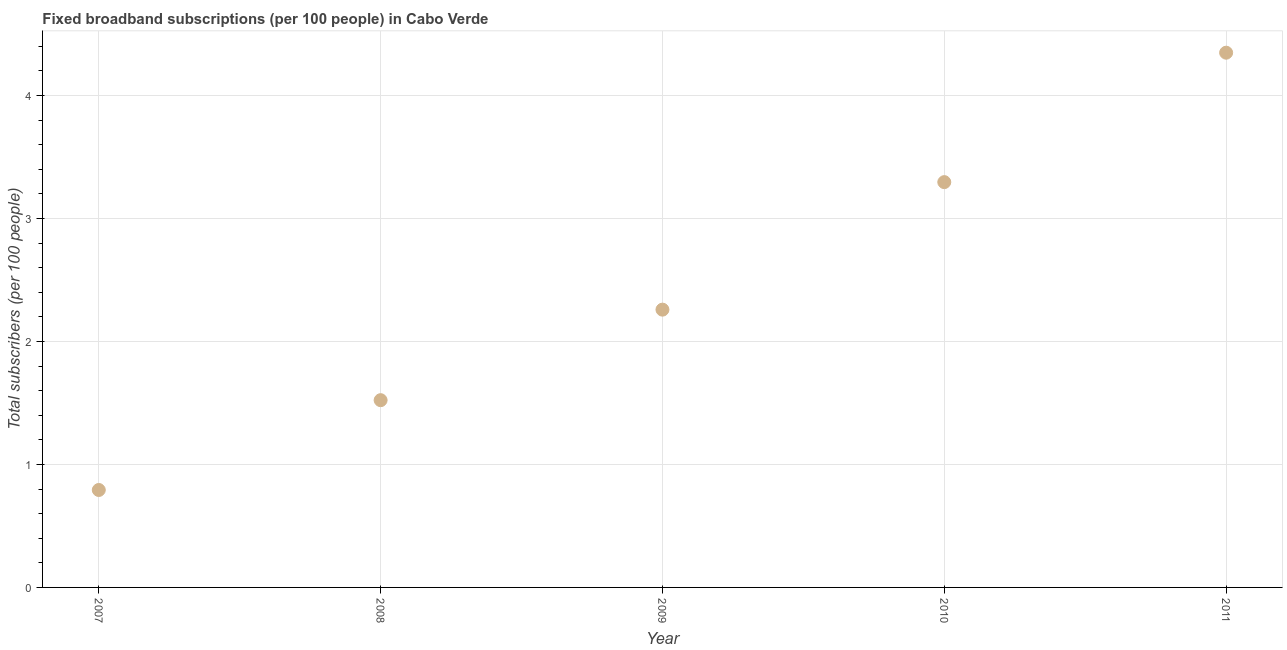What is the total number of fixed broadband subscriptions in 2010?
Offer a terse response. 3.3. Across all years, what is the maximum total number of fixed broadband subscriptions?
Your answer should be very brief. 4.35. Across all years, what is the minimum total number of fixed broadband subscriptions?
Make the answer very short. 0.79. In which year was the total number of fixed broadband subscriptions minimum?
Provide a short and direct response. 2007. What is the sum of the total number of fixed broadband subscriptions?
Provide a succinct answer. 12.22. What is the difference between the total number of fixed broadband subscriptions in 2009 and 2010?
Make the answer very short. -1.04. What is the average total number of fixed broadband subscriptions per year?
Provide a succinct answer. 2.44. What is the median total number of fixed broadband subscriptions?
Provide a succinct answer. 2.26. Do a majority of the years between 2011 and 2007 (inclusive) have total number of fixed broadband subscriptions greater than 0.6000000000000001 ?
Offer a very short reply. Yes. What is the ratio of the total number of fixed broadband subscriptions in 2009 to that in 2010?
Give a very brief answer. 0.69. Is the difference between the total number of fixed broadband subscriptions in 2007 and 2008 greater than the difference between any two years?
Offer a terse response. No. What is the difference between the highest and the second highest total number of fixed broadband subscriptions?
Provide a succinct answer. 1.05. Is the sum of the total number of fixed broadband subscriptions in 2008 and 2011 greater than the maximum total number of fixed broadband subscriptions across all years?
Make the answer very short. Yes. What is the difference between the highest and the lowest total number of fixed broadband subscriptions?
Offer a terse response. 3.56. How many years are there in the graph?
Provide a succinct answer. 5. Does the graph contain any zero values?
Offer a terse response. No. Does the graph contain grids?
Provide a succinct answer. Yes. What is the title of the graph?
Give a very brief answer. Fixed broadband subscriptions (per 100 people) in Cabo Verde. What is the label or title of the X-axis?
Your response must be concise. Year. What is the label or title of the Y-axis?
Provide a short and direct response. Total subscribers (per 100 people). What is the Total subscribers (per 100 people) in 2007?
Your response must be concise. 0.79. What is the Total subscribers (per 100 people) in 2008?
Offer a terse response. 1.52. What is the Total subscribers (per 100 people) in 2009?
Give a very brief answer. 2.26. What is the Total subscribers (per 100 people) in 2010?
Your response must be concise. 3.3. What is the Total subscribers (per 100 people) in 2011?
Provide a succinct answer. 4.35. What is the difference between the Total subscribers (per 100 people) in 2007 and 2008?
Your answer should be compact. -0.73. What is the difference between the Total subscribers (per 100 people) in 2007 and 2009?
Provide a succinct answer. -1.47. What is the difference between the Total subscribers (per 100 people) in 2007 and 2010?
Offer a terse response. -2.5. What is the difference between the Total subscribers (per 100 people) in 2007 and 2011?
Keep it short and to the point. -3.56. What is the difference between the Total subscribers (per 100 people) in 2008 and 2009?
Make the answer very short. -0.74. What is the difference between the Total subscribers (per 100 people) in 2008 and 2010?
Your answer should be compact. -1.77. What is the difference between the Total subscribers (per 100 people) in 2008 and 2011?
Ensure brevity in your answer.  -2.83. What is the difference between the Total subscribers (per 100 people) in 2009 and 2010?
Give a very brief answer. -1.04. What is the difference between the Total subscribers (per 100 people) in 2009 and 2011?
Keep it short and to the point. -2.09. What is the difference between the Total subscribers (per 100 people) in 2010 and 2011?
Your answer should be very brief. -1.05. What is the ratio of the Total subscribers (per 100 people) in 2007 to that in 2008?
Your response must be concise. 0.52. What is the ratio of the Total subscribers (per 100 people) in 2007 to that in 2009?
Your response must be concise. 0.35. What is the ratio of the Total subscribers (per 100 people) in 2007 to that in 2010?
Your answer should be compact. 0.24. What is the ratio of the Total subscribers (per 100 people) in 2007 to that in 2011?
Your answer should be compact. 0.18. What is the ratio of the Total subscribers (per 100 people) in 2008 to that in 2009?
Offer a terse response. 0.67. What is the ratio of the Total subscribers (per 100 people) in 2008 to that in 2010?
Your answer should be very brief. 0.46. What is the ratio of the Total subscribers (per 100 people) in 2009 to that in 2010?
Give a very brief answer. 0.69. What is the ratio of the Total subscribers (per 100 people) in 2009 to that in 2011?
Your response must be concise. 0.52. What is the ratio of the Total subscribers (per 100 people) in 2010 to that in 2011?
Ensure brevity in your answer.  0.76. 